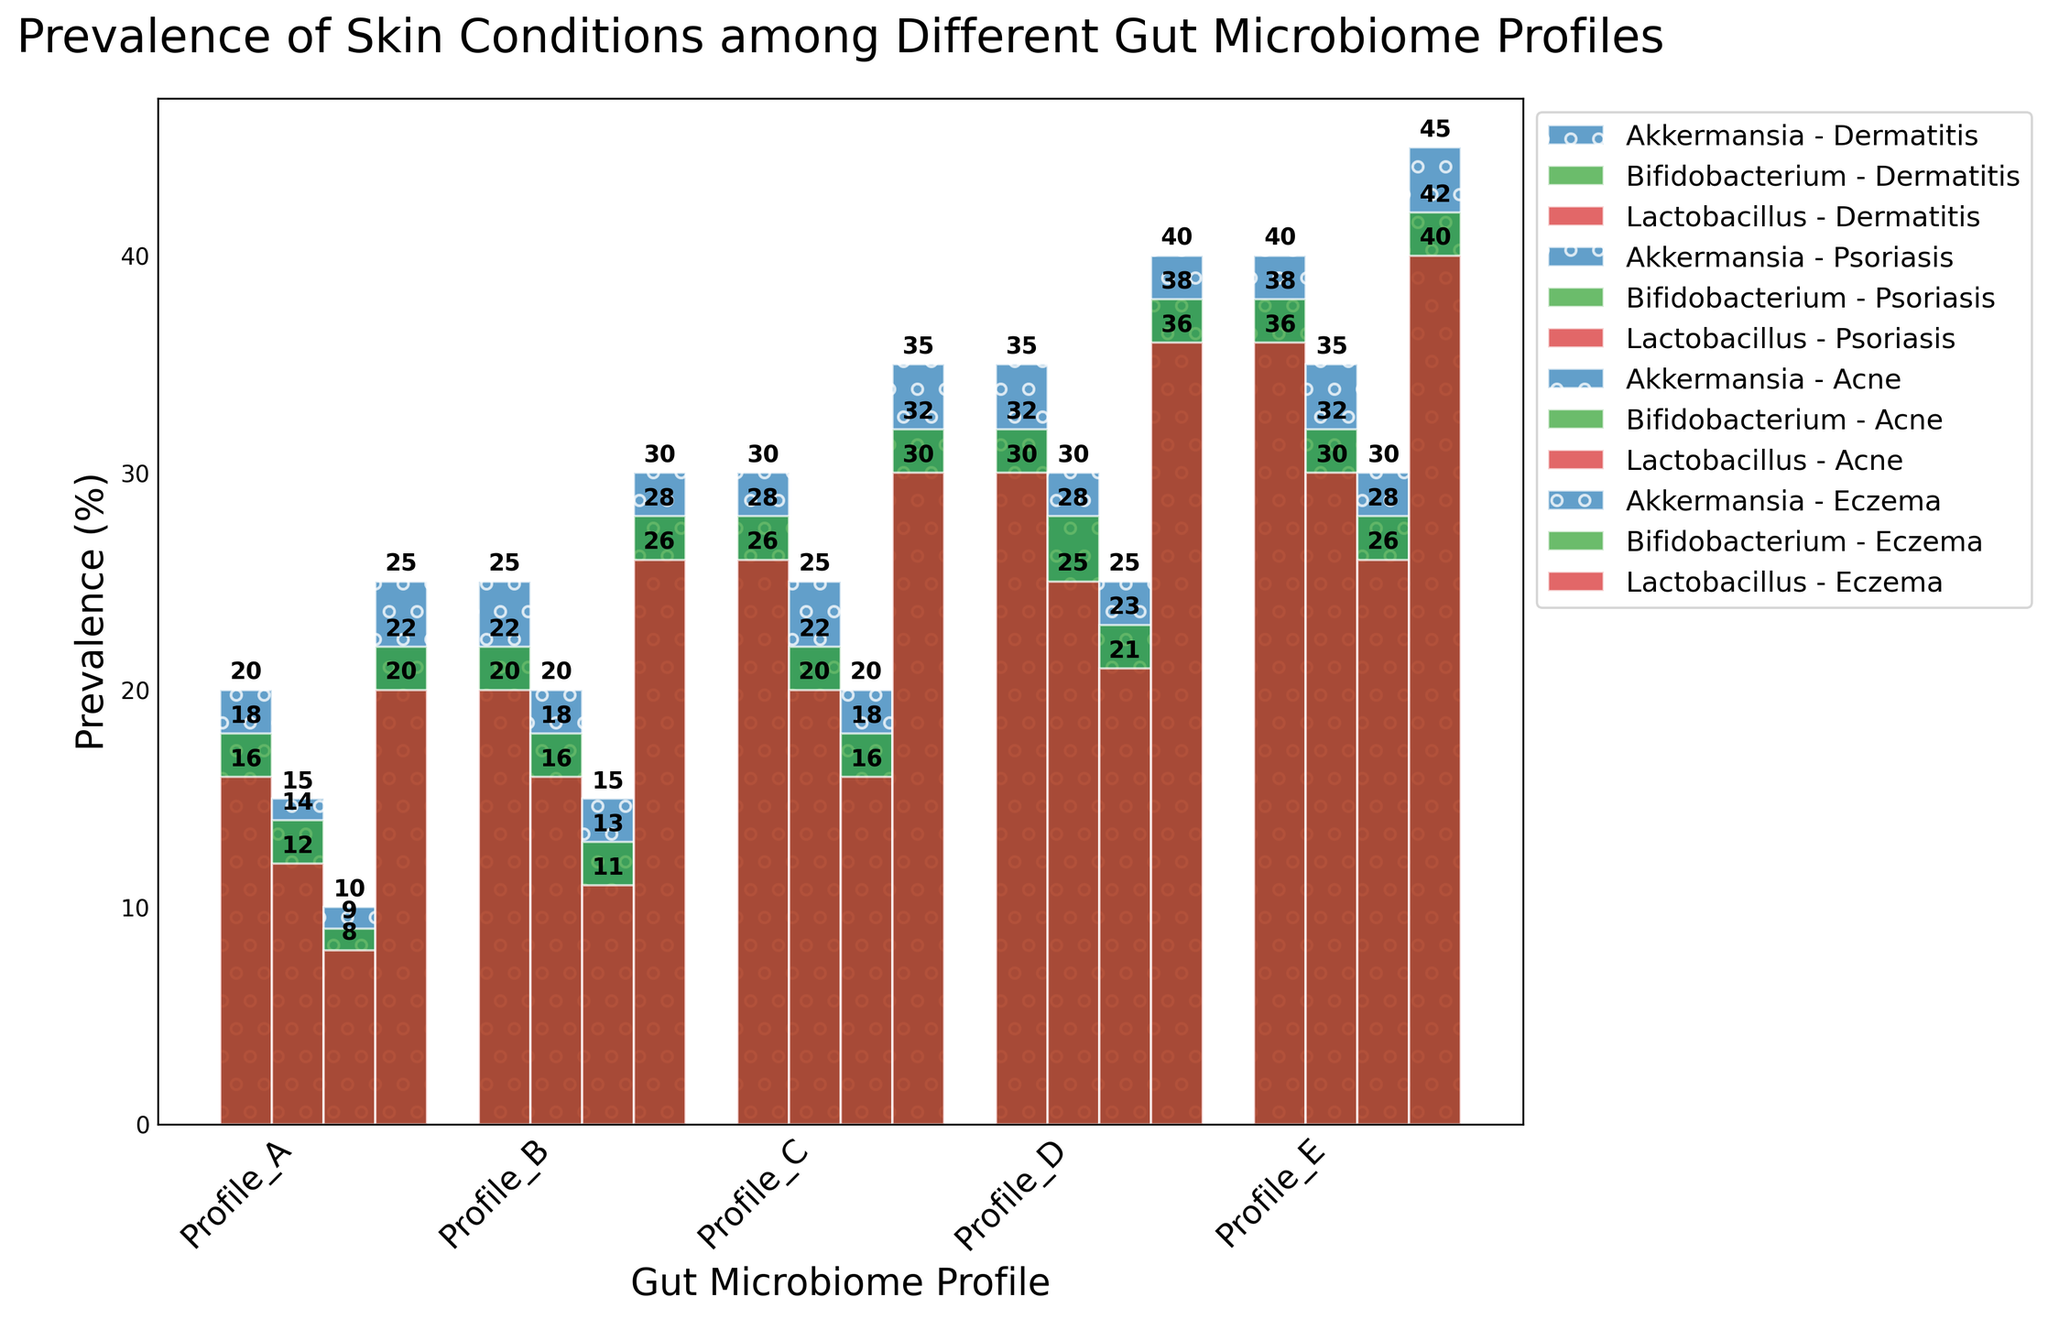What is the most prevalent condition in Gut Microbiome Profile A? To find the most prevalent condition, look at each skin condition (Dermatitis, Psoriasis, Acne, and Eczema) for Profile A and compare their values. The highest value corresponds to Eczema with a prevalence of 25%.
Answer: Eczema Which Gut Microbiome Profile shows the highest prevalence of Psoriasis for Lactobacillus? Check the values for Psoriasis related to Lactobacillus across all profiles (A to E). The highest value is in Profile E with 30%.
Answer: Profile E Calculate the average prevalence of Acne for Bifidobacterium in Profiles B and D. Add the prevalence values for Acne in Profiles B and D (13% and 23%) and divide by 2 to get the average: (13 + 23) / 2 = 18%.
Answer: 18% In Profile C, which bacteria has the highest overall prevalence when summing all skin conditions? Sum the prevalence values for each bacteria (Akkermansia, Bifidobacterium, Lactobacillus) for all conditions (Dermatitis, Psoriasis, Acne, Eczema). Akkermansia: 30+25+20+35=110, Bifidobacterium: 28+22+18+32=100, Lactobacillus: 26+20+16+30=92. The highest is Akkermansia with 110.
Answer: Akkermansia Compare the prevalence of Dermatitis in Gut Microbiome Profile E for Akkermansia and Lactobacillus. Which one is higher and by how much? Look at the prevalence values for Dermatitis in Profile E for Akkermansia and Lactobacillus (40% and 36%). Subtract the smaller value from the larger to find the difference: 40 - 36 = 4%. Akkermansia is higher by 4%.
Answer: Akkermansia by 4% Which skin condition has the least prevalence in Profile D for Bifidobacterium? Examine the prevalence values for Bifidobacterium in Profile D across all skin conditions (Dermatitis: 32%, Psoriasis: 28%, Acne: 23%, Eczema: 38%). The least prevalent condition is Acne with 23%.
Answer: Acne How much higher is the prevalence of Eczema in Profile A compared to Profile B for Lactobacillus? Compare the Eczema values for Lactobacillus between Profile A and Profile B (20% and 26%). Subtract the smaller value from the larger to get the difference: 26 - 20 = 6%.
Answer: 6% What is the sum of all prevalence values for Psoriasis in Profile D? Add the Psoriasis values for all bacteria in Profile D (Akkermansia: 30%, Bifidobacterium: 28%, Lactobacillus: 25%). The sum is 30 + 28 + 25 = 83%.
Answer: 83% Identify the trend in the prevalence of Dermatitis for Akkermansia from Profile A to Profile E. Examine the prevalence values of Dermatitis for Akkermansia across profiles A to E (20%, 25%, 30%, 35%, 40%). The trend shows a consistent increase.
Answer: Increasing 